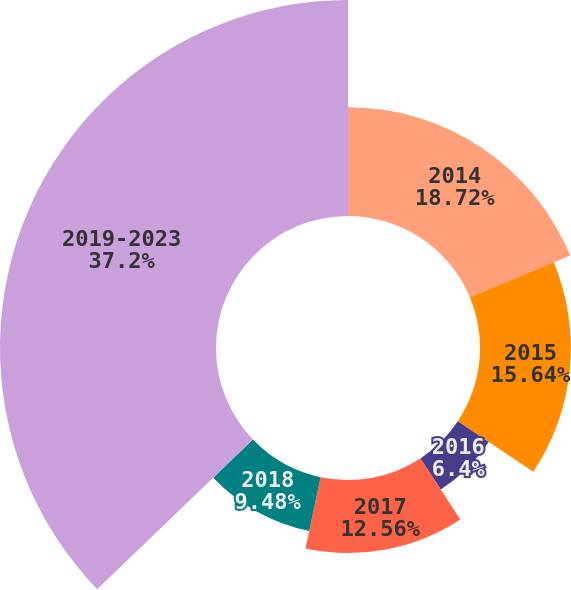Convert chart to OTSL. <chart><loc_0><loc_0><loc_500><loc_500><pie_chart><fcel>2014<fcel>2015<fcel>2016<fcel>2017<fcel>2018<fcel>2019-2023<nl><fcel>18.72%<fcel>15.64%<fcel>6.4%<fcel>12.56%<fcel>9.48%<fcel>37.19%<nl></chart> 